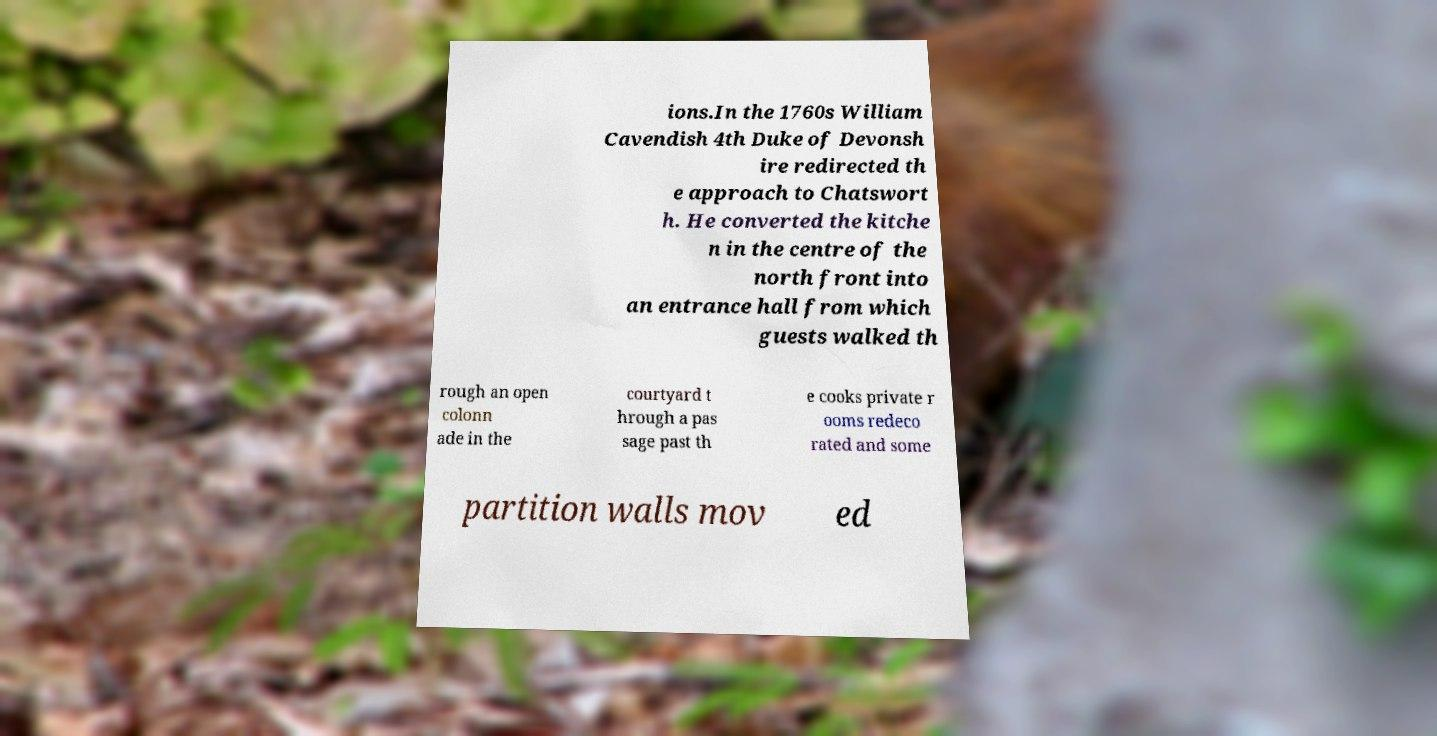Could you assist in decoding the text presented in this image and type it out clearly? ions.In the 1760s William Cavendish 4th Duke of Devonsh ire redirected th e approach to Chatswort h. He converted the kitche n in the centre of the north front into an entrance hall from which guests walked th rough an open colonn ade in the courtyard t hrough a pas sage past th e cooks private r ooms redeco rated and some partition walls mov ed 